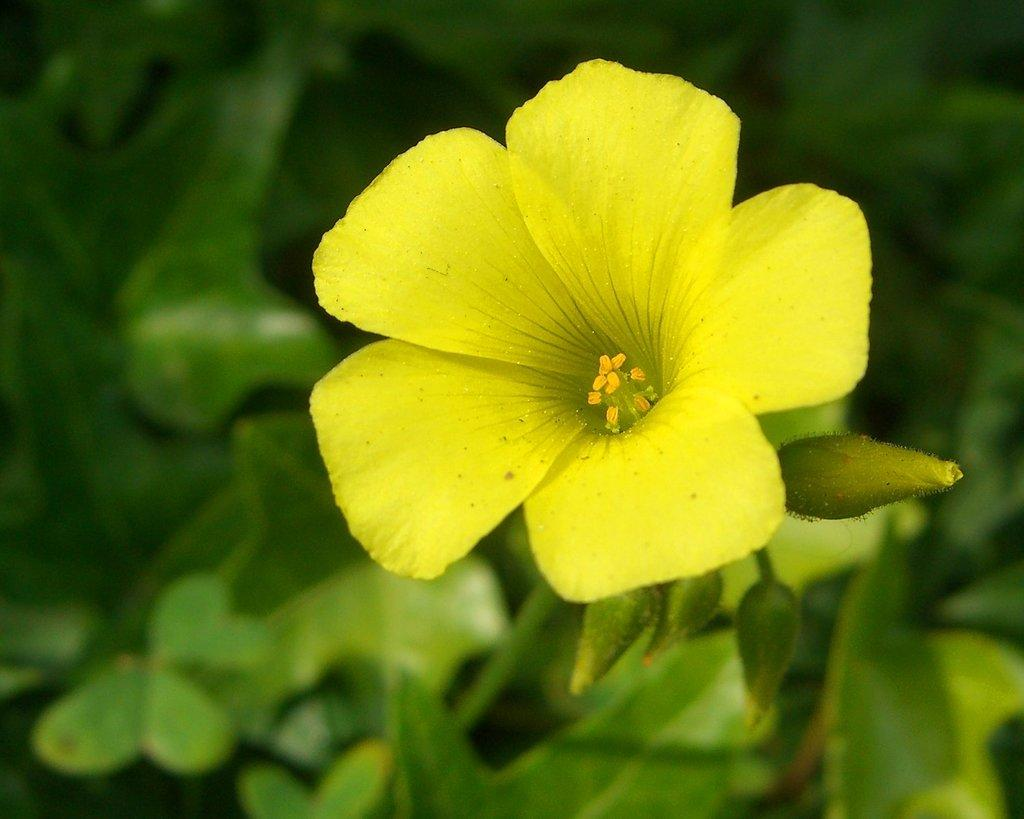What type of flower is present in the image? There is a yellow flower in the image. What color are the leaves in the image? The leaves in the image are green. Can you describe the background of the image? The background of the image is blurred. What type of wood is used to make the cake in the image? There is no cake present in the image, so it is not possible to determine what type of wood might be used. 